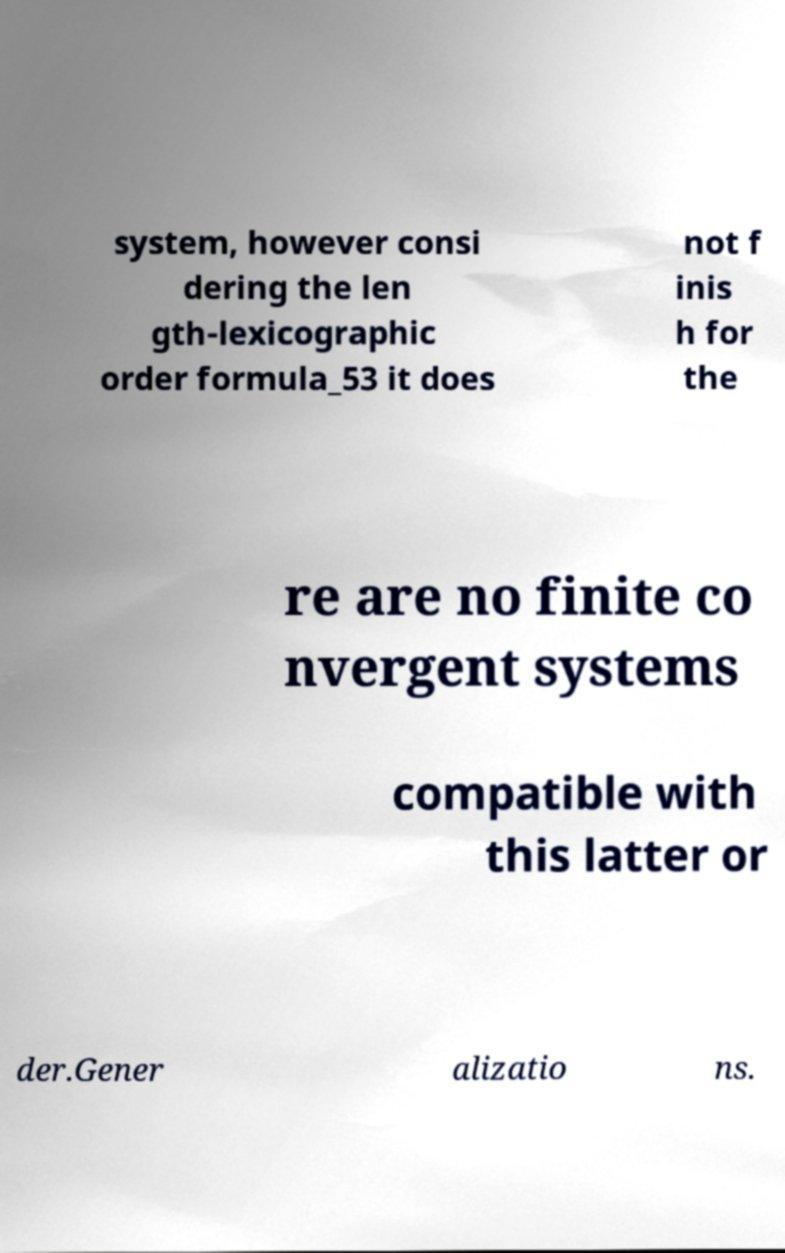Please identify and transcribe the text found in this image. system, however consi dering the len gth-lexicographic order formula_53 it does not f inis h for the re are no finite co nvergent systems compatible with this latter or der.Gener alizatio ns. 